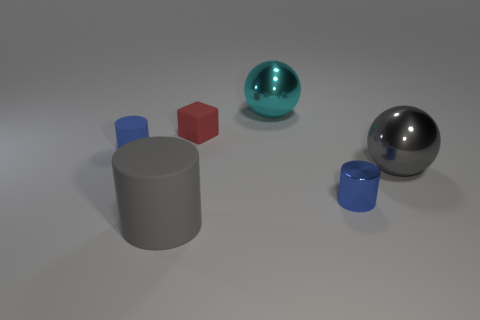There is a gray thing that is the same shape as the cyan object; what is it made of? metal 